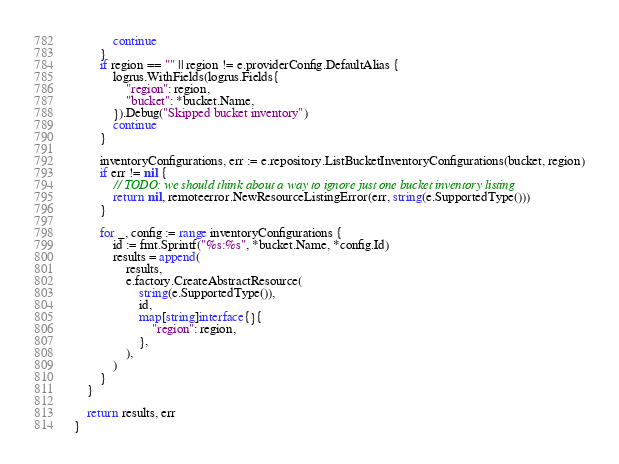Convert code to text. <code><loc_0><loc_0><loc_500><loc_500><_Go_>			continue
		}
		if region == "" || region != e.providerConfig.DefaultAlias {
			logrus.WithFields(logrus.Fields{
				"region": region,
				"bucket": *bucket.Name,
			}).Debug("Skipped bucket inventory")
			continue
		}

		inventoryConfigurations, err := e.repository.ListBucketInventoryConfigurations(bucket, region)
		if err != nil {
			// TODO: we should think about a way to ignore just one bucket inventory listing
			return nil, remoteerror.NewResourceListingError(err, string(e.SupportedType()))
		}

		for _, config := range inventoryConfigurations {
			id := fmt.Sprintf("%s:%s", *bucket.Name, *config.Id)
			results = append(
				results,
				e.factory.CreateAbstractResource(
					string(e.SupportedType()),
					id,
					map[string]interface{}{
						"region": region,
					},
				),
			)
		}
	}

	return results, err
}
</code> 